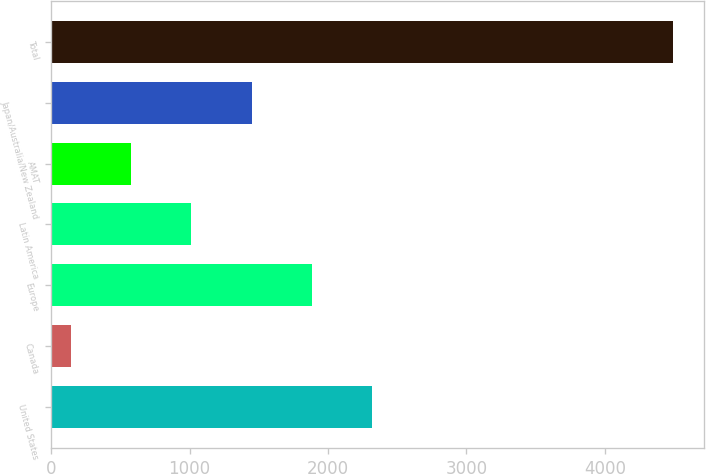Convert chart to OTSL. <chart><loc_0><loc_0><loc_500><loc_500><bar_chart><fcel>United States<fcel>Canada<fcel>Europe<fcel>Latin America<fcel>AMAT<fcel>Japan/Australia/New Zealand<fcel>Total<nl><fcel>2317.55<fcel>145<fcel>1883.04<fcel>1014.02<fcel>579.51<fcel>1448.53<fcel>4490.1<nl></chart> 